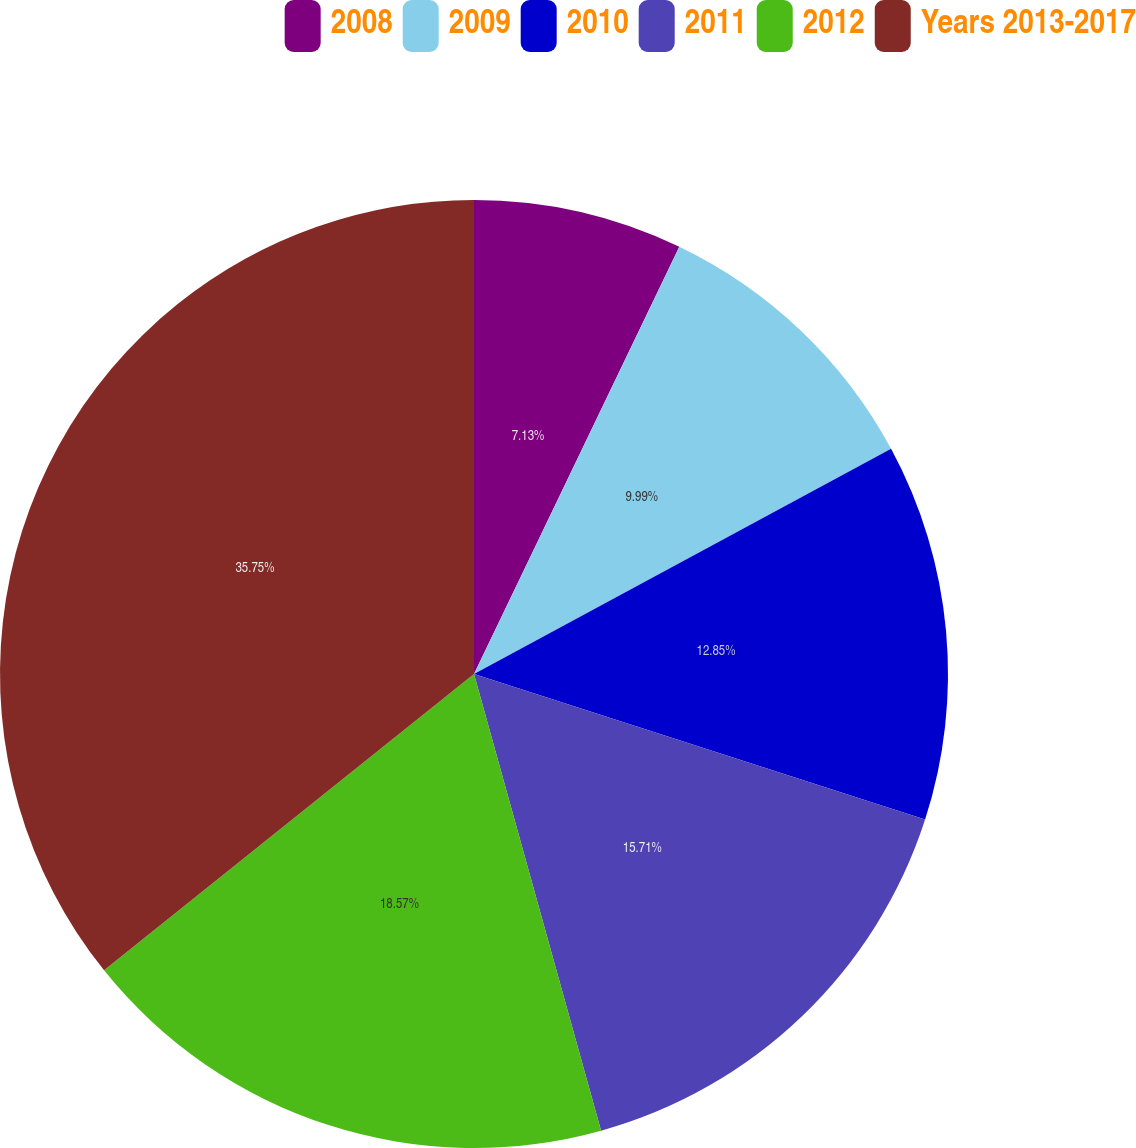Convert chart. <chart><loc_0><loc_0><loc_500><loc_500><pie_chart><fcel>2008<fcel>2009<fcel>2010<fcel>2011<fcel>2012<fcel>Years 2013-2017<nl><fcel>7.13%<fcel>9.99%<fcel>12.85%<fcel>15.71%<fcel>18.57%<fcel>35.75%<nl></chart> 